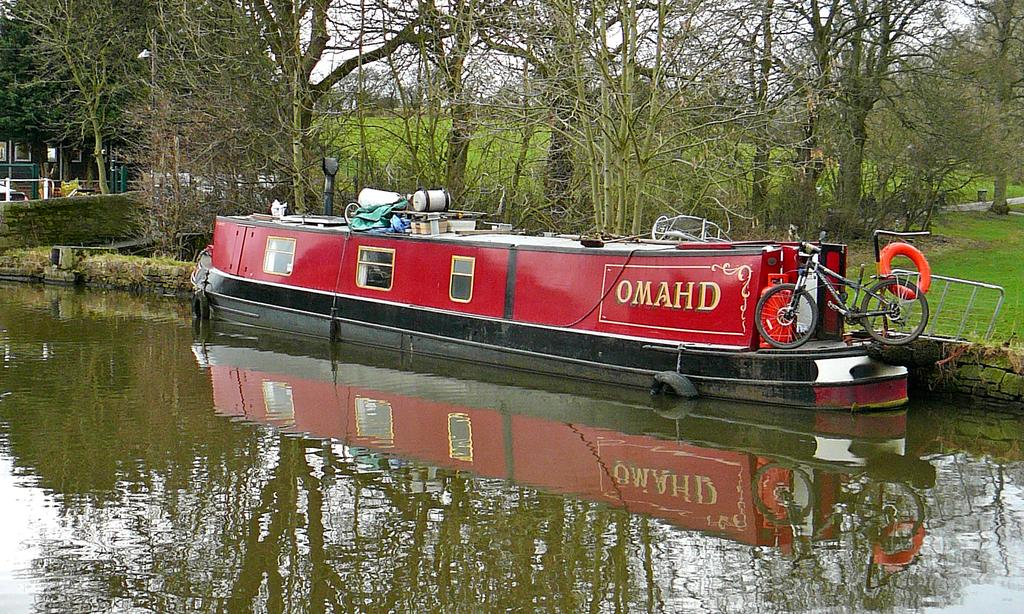What is the color of the boat in the image? The boat in the image is red and black. What is on the boat in the image? There is a bicycle and other objects on the boat. What can be seen in the background of the image? Trees, water, a building, and the sky are visible in the image. What is the color of the sky in the image? The sky is in white color. Are there any visible openings in the building? Yes, there are windows visible in the image. What type of soup is being served in the image? There is no soup present in the image; it features a boat with a bicycle and other objects on it. 